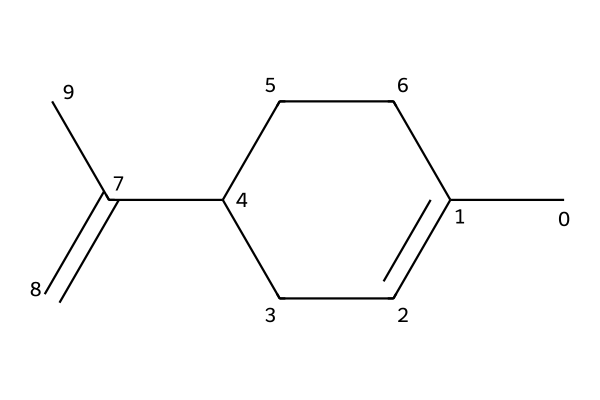What is the molecular formula of limonene? To determine the molecular formula, we count the number of carbon (C) and hydrogen (H) atoms in the SMILES representation. In the structure CC1=CCC(CC1)C(=C)C, we see there are 10 carbon atoms and 16 hydrogen atoms. Therefore, the molecular formula is C10H16.
Answer: C10H16 How many double bonds are present in limonene? In the structure CC1=CCC(CC1)C(=C)C, we identify two locations where there are double bonds indicated by the '=' sign. Counting these gives us a total of 2 double bonds.
Answer: 2 What type of compound is limonene? Limonene is primarily known as a terpene due to its hydrocarbon structure consisting of multiple double bonds and its occurrence in the essential oils of plants.
Answer: terpene How many rings are in the limonene structure? In analyzing the SMILES representation, CC1=CCC(CC1)C(=C)C, the 'C1...' notation indicates the presence of a ring structure. Here, there is one cyclic component, thus there is 1 ring.
Answer: 1 What is the significance of limonene's structure in relation to its scent? Limonene has a specific arrangement of carbon atoms and double bonds that contributes to its appealing citrus scent. The hydrophobic nature of the hydrocarbon structure and the specific configuration around the double bonds enhance its aromatic properties, making it fragrant.
Answer: citrus scent Is limonene classified as a saturated or unsaturated compound? By identifying the presence of double bonds in the structure CC1=CCC(CC1)C(=C)C, we can conclude that limonene is unsaturated. Saturated compounds have only single bonds, while the presence of double bonds classifies it as unsaturated.
Answer: unsaturated 